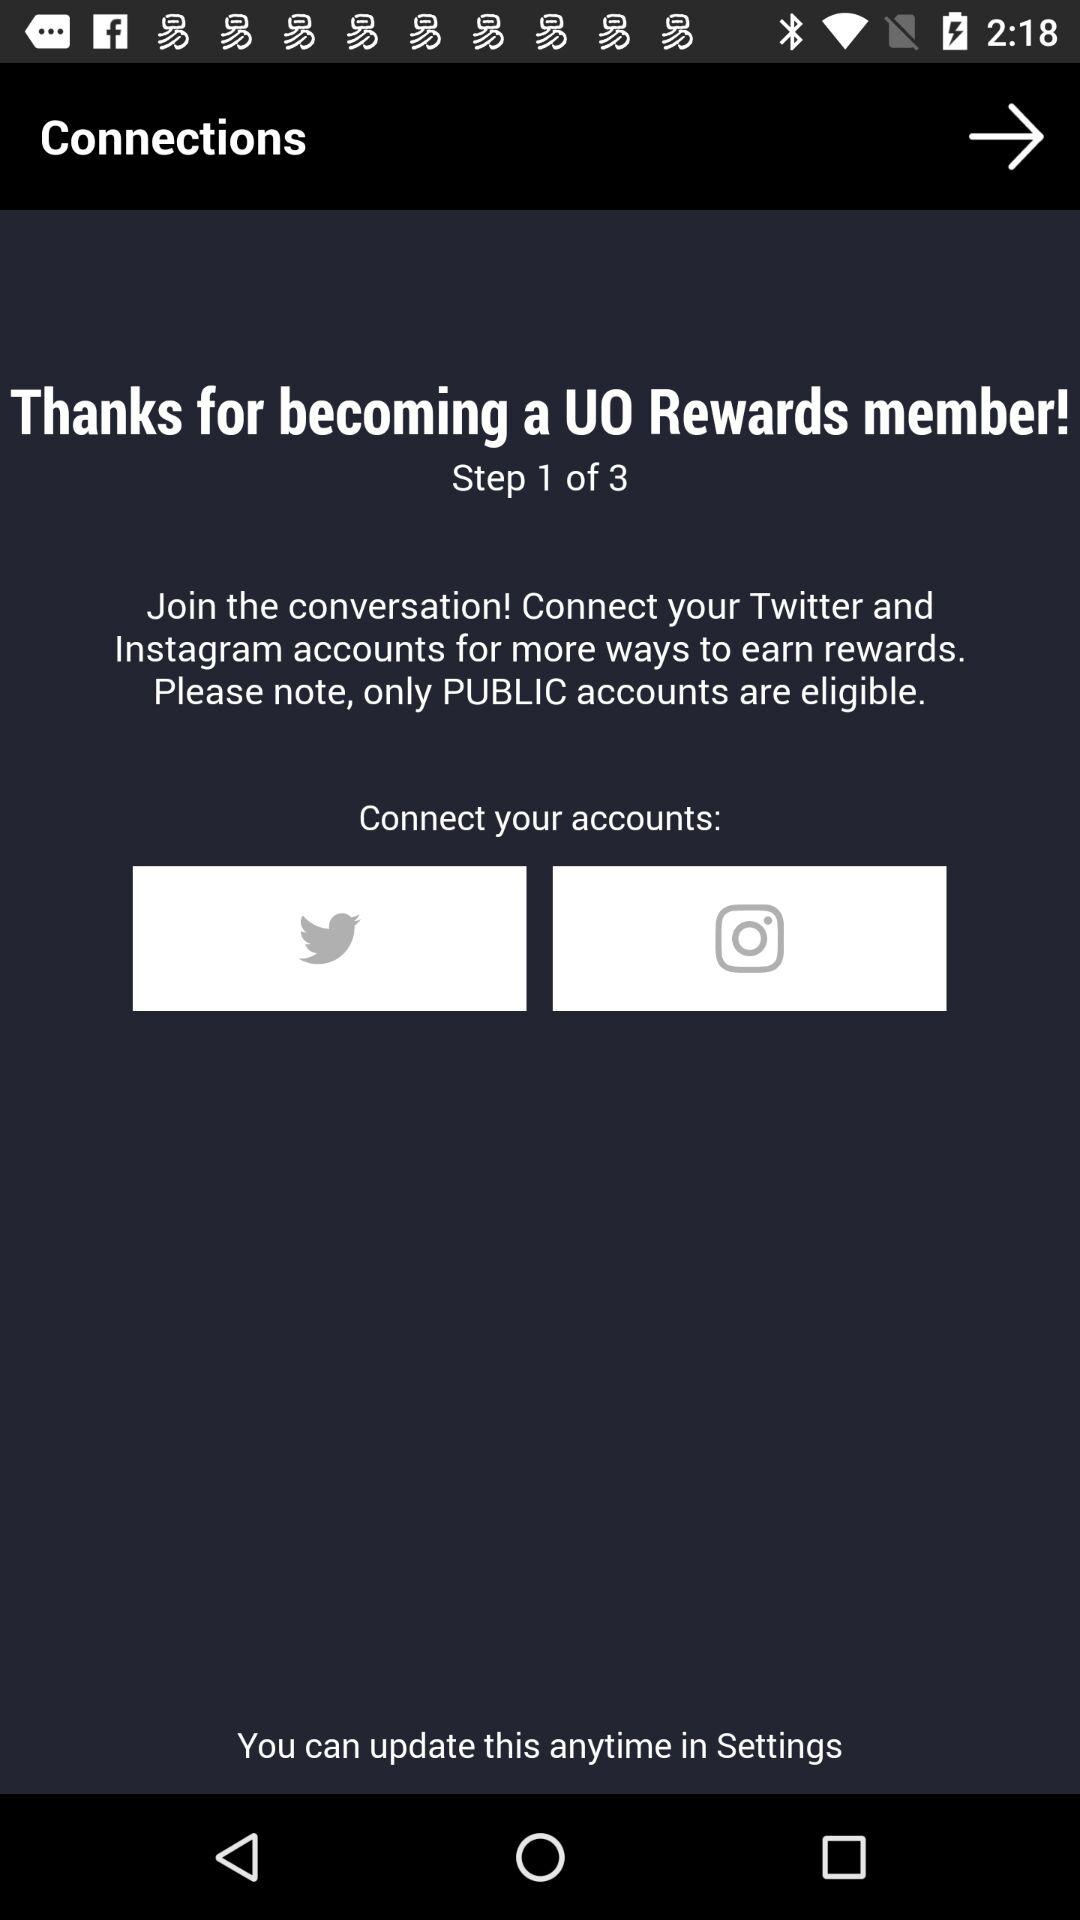Why is the "Thanks" message shown on the screen? The "Thanks" message is shown on the screen for becoming a UO Rewards member. 